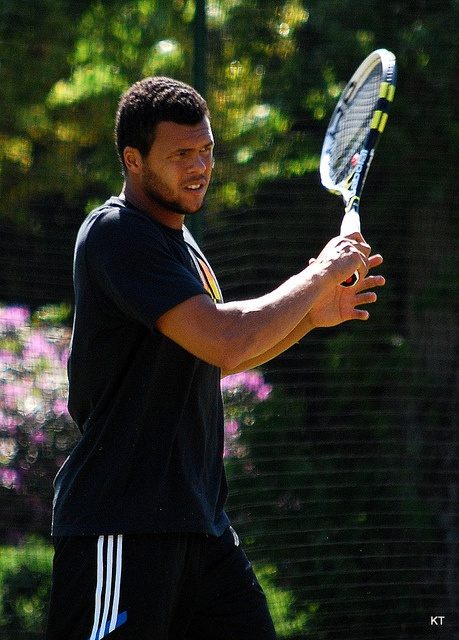Describe the objects in this image and their specific colors. I can see people in black, maroon, brown, and white tones and tennis racket in black, white, darkgray, and gray tones in this image. 